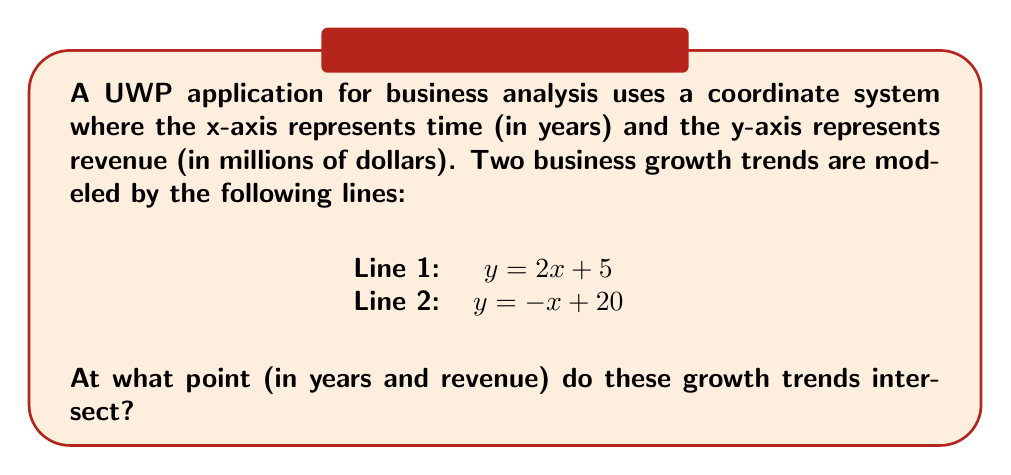Help me with this question. To find the intersection point of these two lines, we need to solve the system of equations:

$$\begin{cases}
y = 2x + 5 \\
y = -x + 20
\end{cases}$$

Step 1: Set the equations equal to each other since they represent the same point.
$2x + 5 = -x + 20$

Step 2: Solve for x by adding x to both sides and subtracting 5 from both sides.
$3x = 15$
$x = 5$

Step 3: Substitute x = 5 into either of the original equations to find y. Let's use the first equation:
$y = 2(5) + 5 = 10 + 5 = 15$

Step 4: Interpret the result in the context of the business application:
The x-coordinate (5) represents 5 years from the starting point.
The y-coordinate (15) represents $15 million in revenue.

Therefore, the two growth trends intersect at the point (5, 15), which means after 5 years, both trends predict a revenue of $15 million.
Answer: (5, 15) 